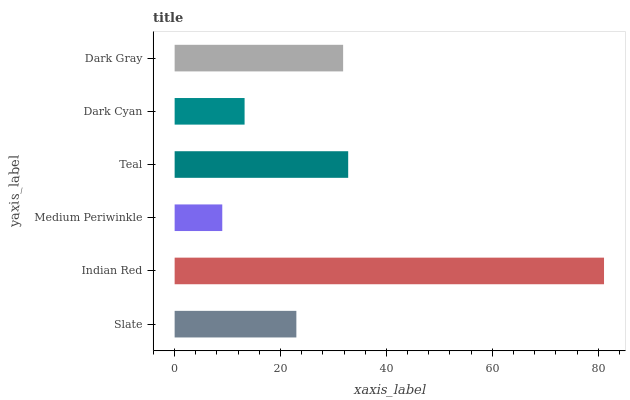Is Medium Periwinkle the minimum?
Answer yes or no. Yes. Is Indian Red the maximum?
Answer yes or no. Yes. Is Indian Red the minimum?
Answer yes or no. No. Is Medium Periwinkle the maximum?
Answer yes or no. No. Is Indian Red greater than Medium Periwinkle?
Answer yes or no. Yes. Is Medium Periwinkle less than Indian Red?
Answer yes or no. Yes. Is Medium Periwinkle greater than Indian Red?
Answer yes or no. No. Is Indian Red less than Medium Periwinkle?
Answer yes or no. No. Is Dark Gray the high median?
Answer yes or no. Yes. Is Slate the low median?
Answer yes or no. Yes. Is Slate the high median?
Answer yes or no. No. Is Dark Cyan the low median?
Answer yes or no. No. 